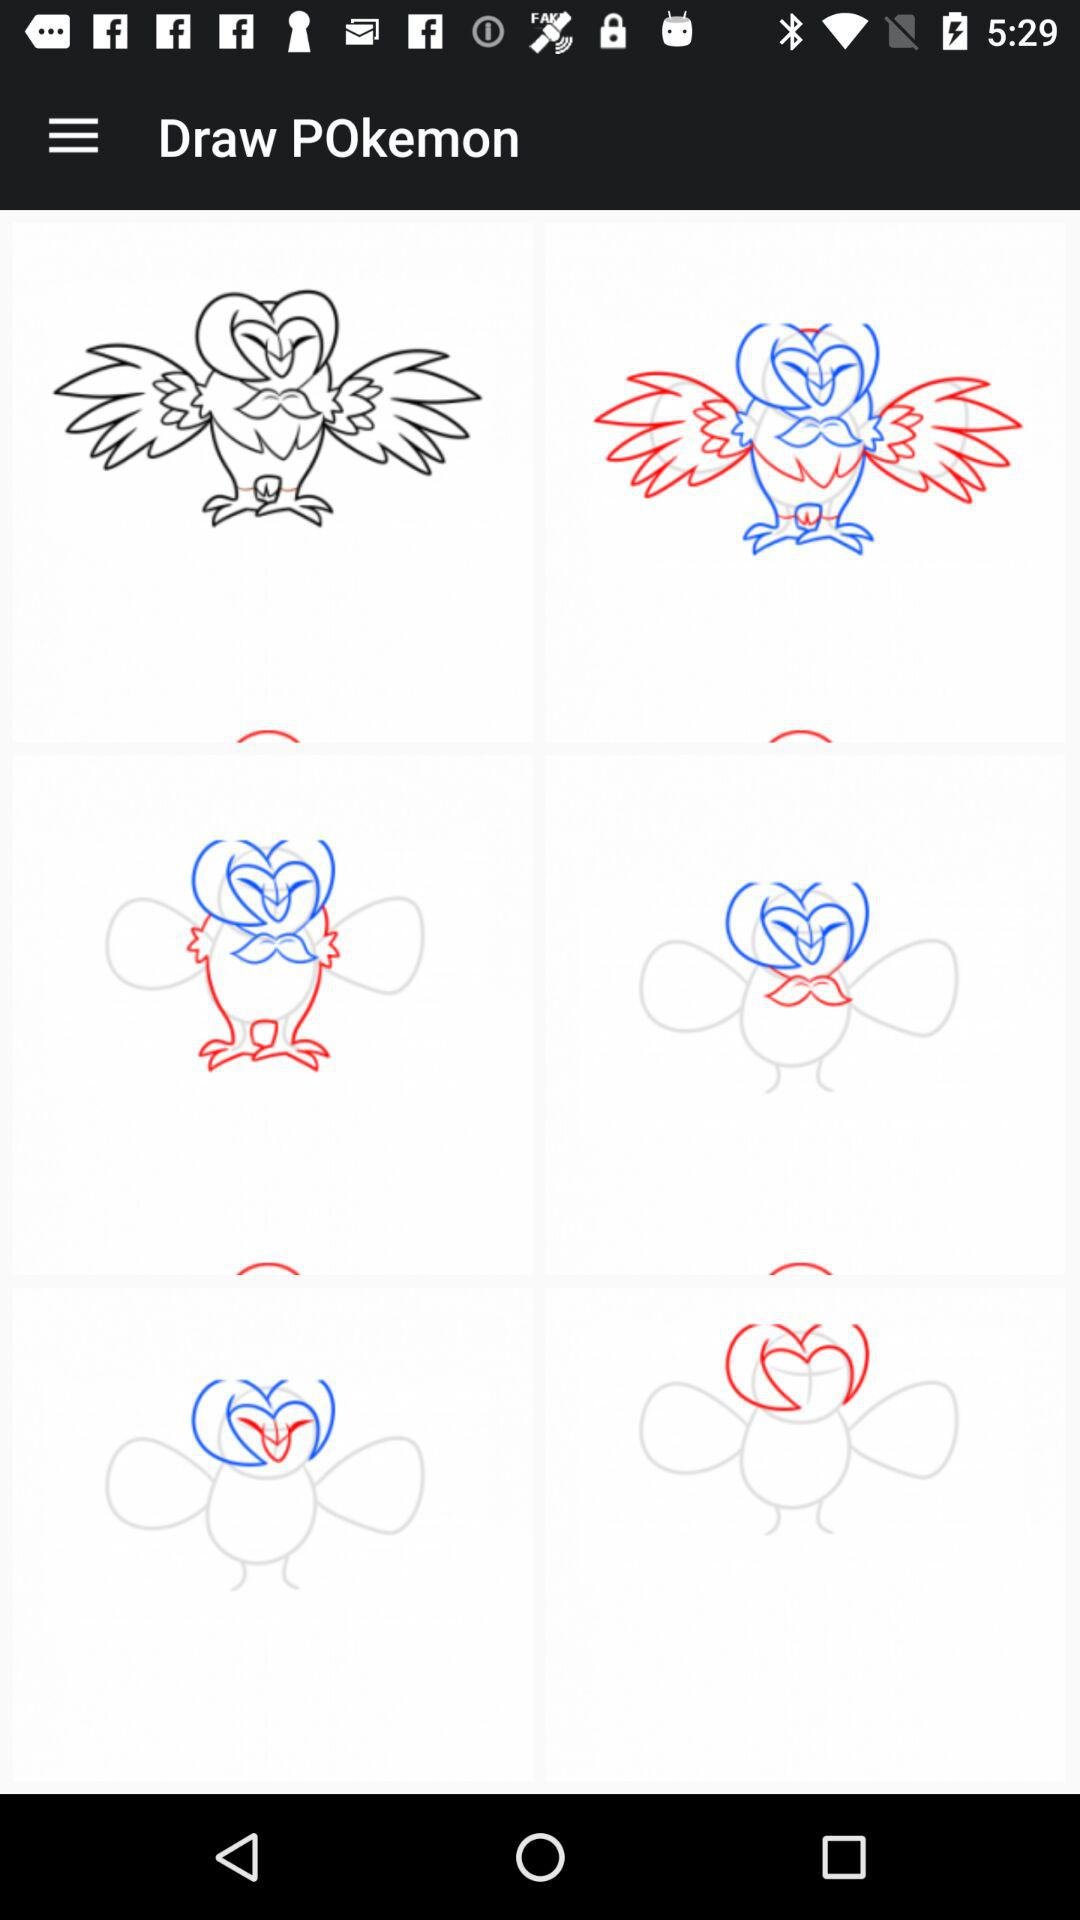What is the name of the application? The name of the application is "Draw POkemon". 